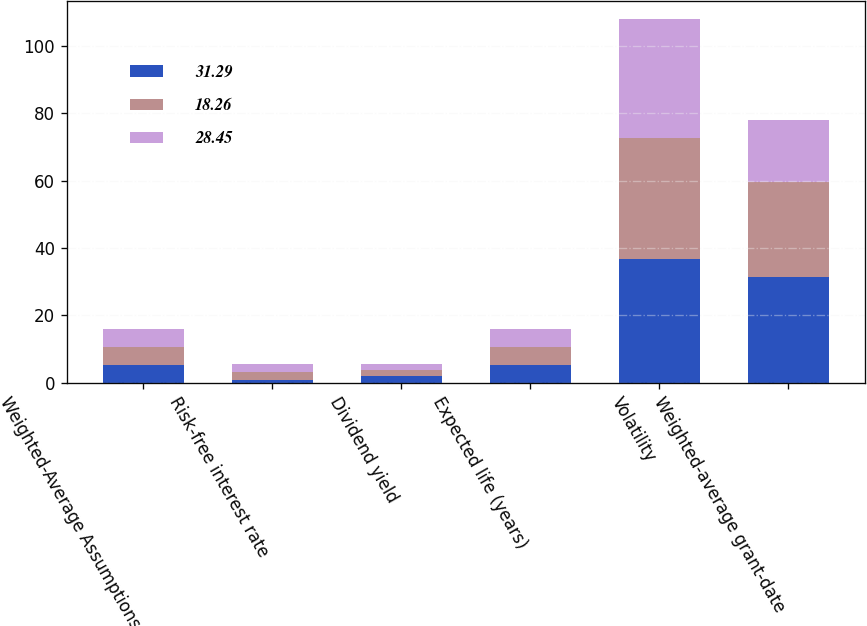Convert chart. <chart><loc_0><loc_0><loc_500><loc_500><stacked_bar_chart><ecel><fcel>Weighted-Average Assumptions<fcel>Risk-free interest rate<fcel>Dividend yield<fcel>Expected life (years)<fcel>Volatility<fcel>Weighted-average grant-date<nl><fcel>31.29<fcel>5.3<fcel>0.8<fcel>2.1<fcel>5.3<fcel>36.8<fcel>31.29<nl><fcel>18.26<fcel>5.3<fcel>2.3<fcel>1.6<fcel>5.3<fcel>35.9<fcel>28.45<nl><fcel>28.45<fcel>5.3<fcel>2.4<fcel>1.8<fcel>5.4<fcel>35.2<fcel>18.26<nl></chart> 